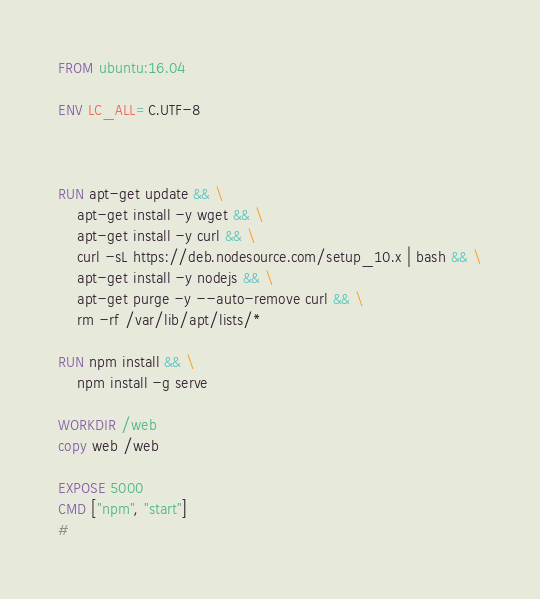<code> <loc_0><loc_0><loc_500><loc_500><_Dockerfile_>FROM ubuntu:16.04 

ENV LC_ALL=C.UTF-8 



RUN apt-get update && \
    apt-get install -y wget && \
    apt-get install -y curl && \
    curl -sL https://deb.nodesource.com/setup_10.x | bash && \
    apt-get install -y nodejs && \
	apt-get purge -y --auto-remove curl && \ 
    rm -rf /var/lib/apt/lists/* 

RUN npm install && \
    npm install -g serve

WORKDIR /web
copy web /web

EXPOSE 5000
CMD ["npm", "start"]
#</code> 